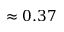Convert formula to latex. <formula><loc_0><loc_0><loc_500><loc_500>\approx 0 . 3 7</formula> 